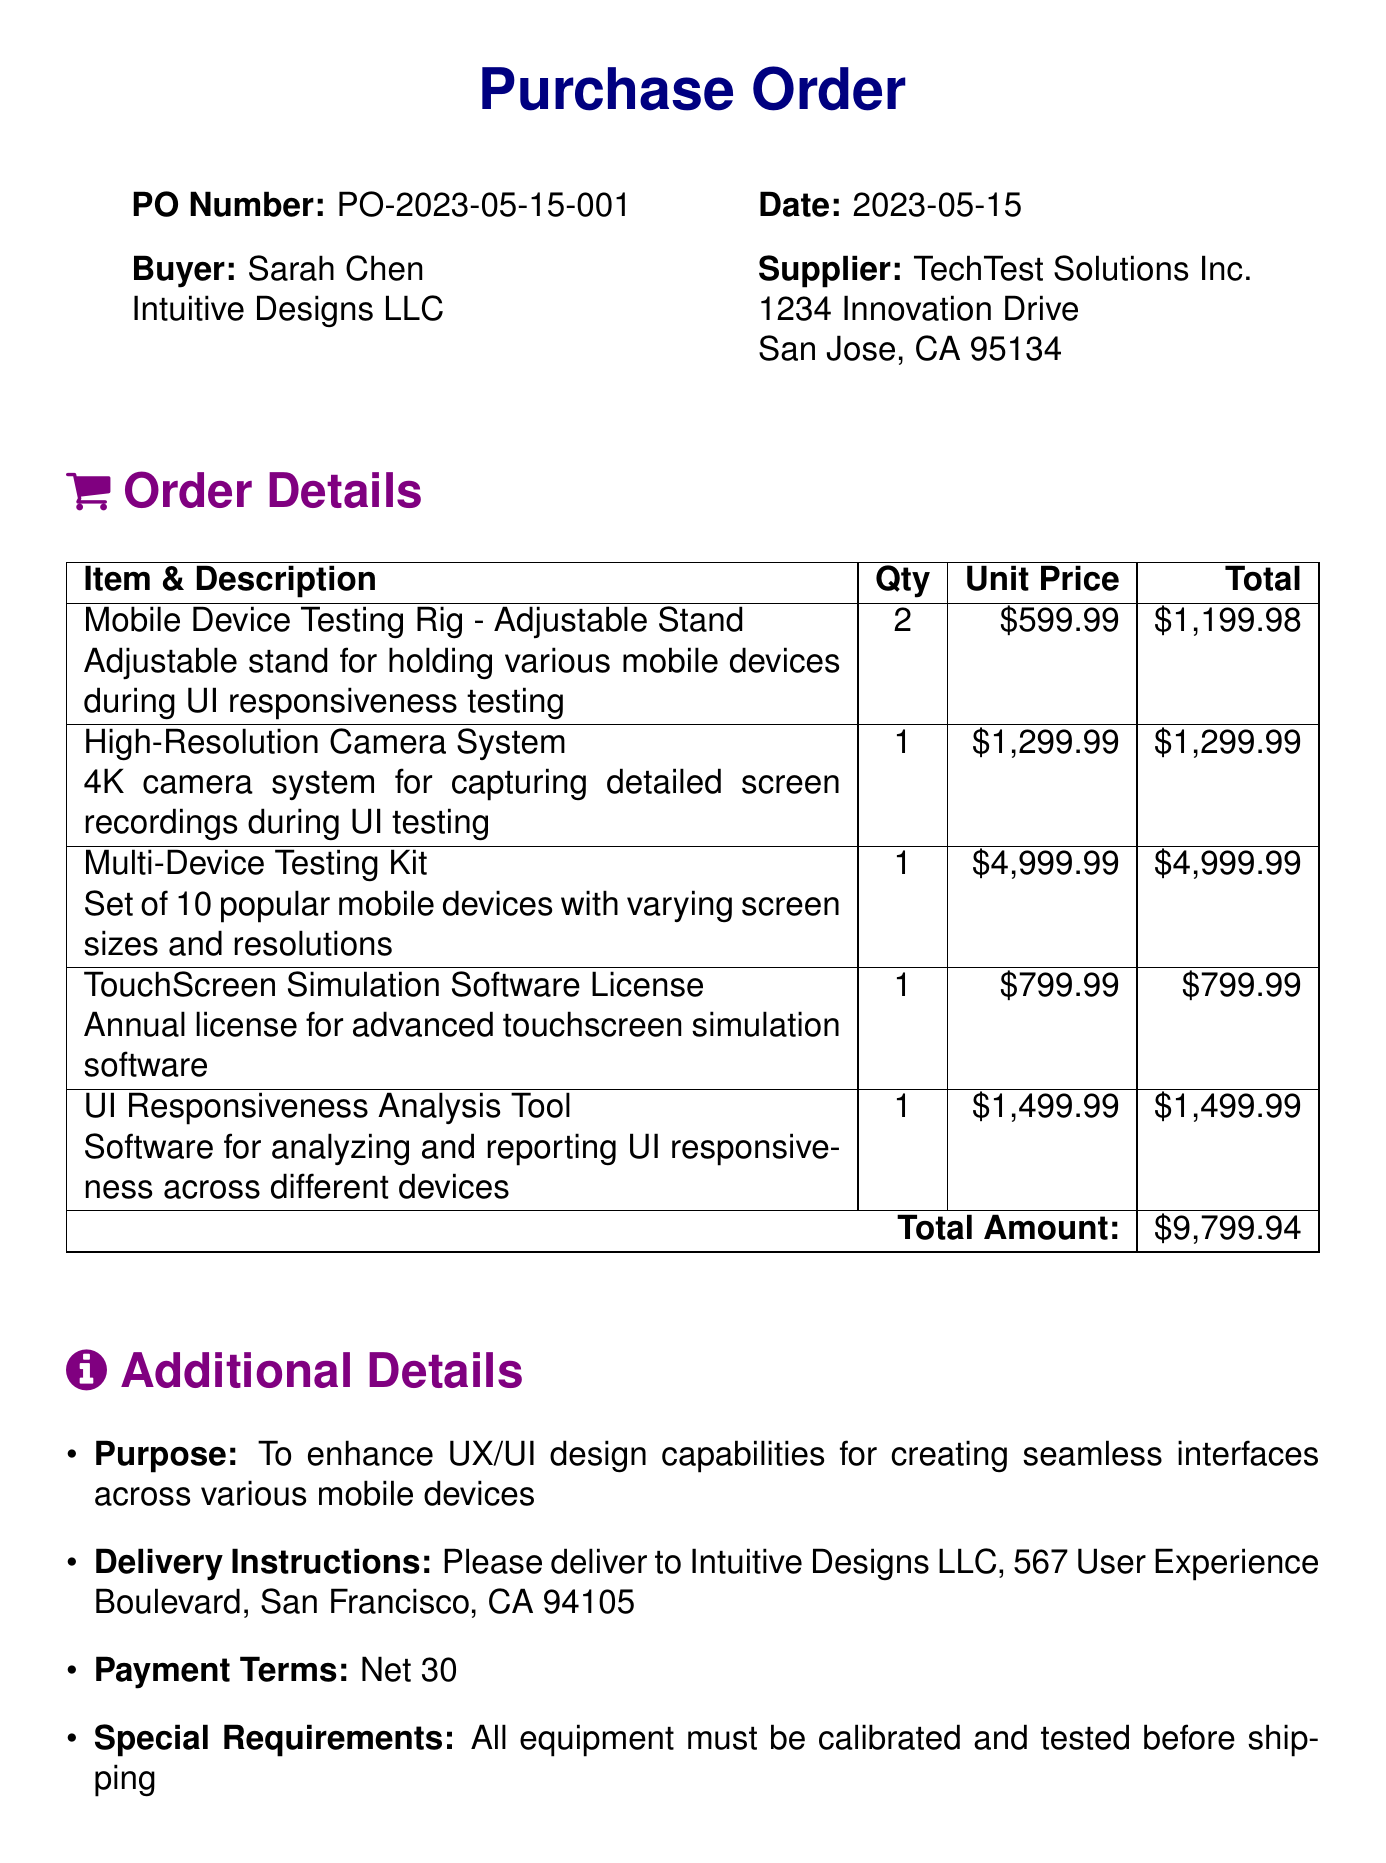What is the purchase order number? The purchase order number is mentioned in the header of the document.
Answer: PO-2023-05-15-001 Who is the buyer? The buyer's name and company are listed at the top of the document.
Answer: Sarah Chen, Intuitive Designs LLC What is the total amount? The total amount is stated at the end of the order details section.
Answer: $9799.94 How many units of the Mobile Device Testing Rig were ordered? The quantity for the Mobile Device Testing Rig is indicated in the order details.
Answer: 2 What is the purpose of the purchase order? The purpose is described in the additional details section.
Answer: To enhance UX/UI design capabilities for creating seamless interfaces across various mobile devices Who approved the purchase order? The approvals section contains the name of the person who approved the document.
Answer: Michael Rodriguez What are the payment terms? The payment terms are specified in the additional details of the document.
Answer: Net 30 What software license is included in the order? The name of the included software license is found in the order details related to item description.
Answer: TouchScreen Simulation Software License What is the delivery address? The delivery address is specified under additional details in the document.
Answer: 567 User Experience Boulevard, San Francisco, CA 94105 